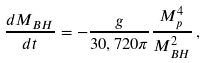<formula> <loc_0><loc_0><loc_500><loc_500>\frac { d M _ { B H } } { d t } = - \frac { g } { 3 0 , 7 2 0 \pi } \frac { M _ { p } ^ { 4 } } { M _ { B H } ^ { 2 } } \, ,</formula> 